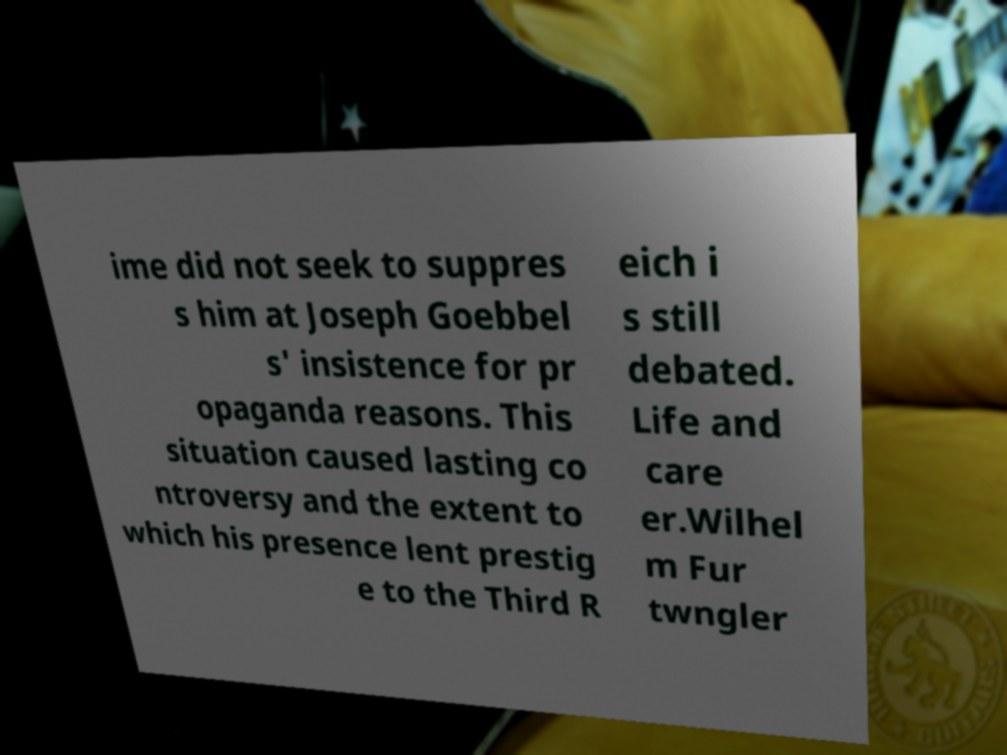Please read and relay the text visible in this image. What does it say? ime did not seek to suppres s him at Joseph Goebbel s' insistence for pr opaganda reasons. This situation caused lasting co ntroversy and the extent to which his presence lent prestig e to the Third R eich i s still debated. Life and care er.Wilhel m Fur twngler 